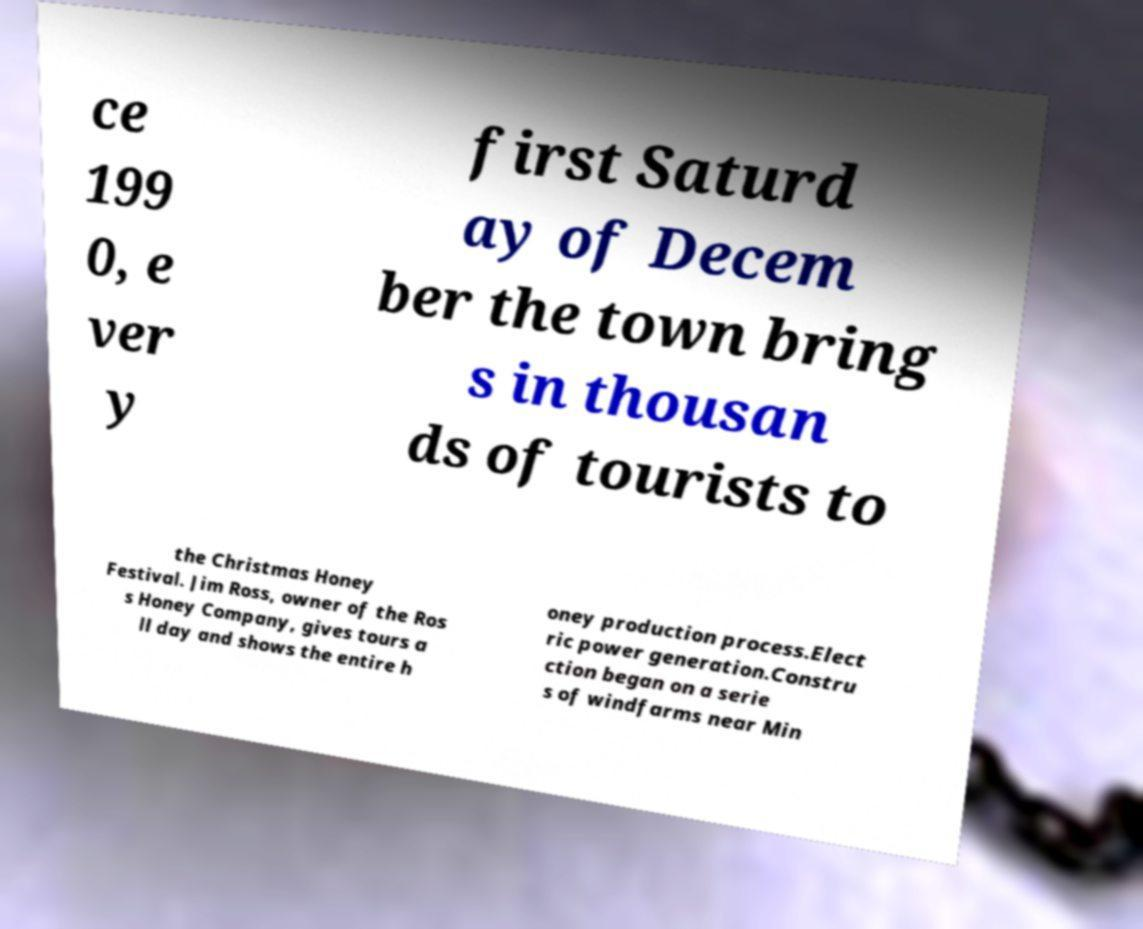There's text embedded in this image that I need extracted. Can you transcribe it verbatim? ce 199 0, e ver y first Saturd ay of Decem ber the town bring s in thousan ds of tourists to the Christmas Honey Festival. Jim Ross, owner of the Ros s Honey Company, gives tours a ll day and shows the entire h oney production process.Elect ric power generation.Constru ction began on a serie s of windfarms near Min 